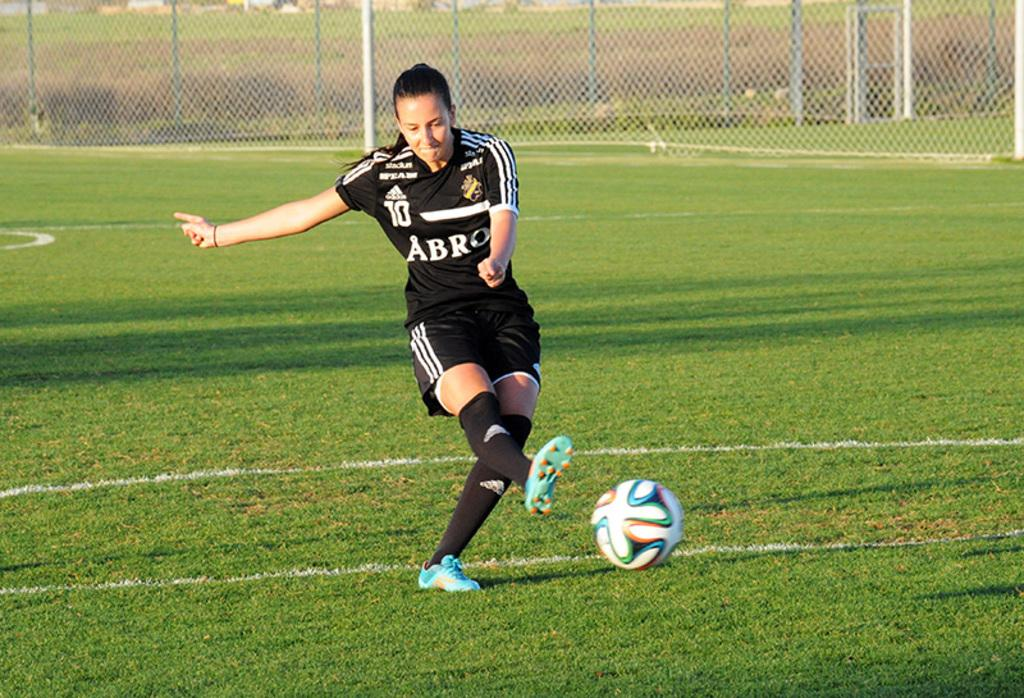What is the person in the image doing? The person is kicking a ball. What can be seen in the background of the image? There is wire fencing, plants, and grass in the background of the image. What type of disgust can be seen on the person's face while kicking the ball? There is no indication of disgust on the person's face in the image; they appear to be focused on kicking the ball. 